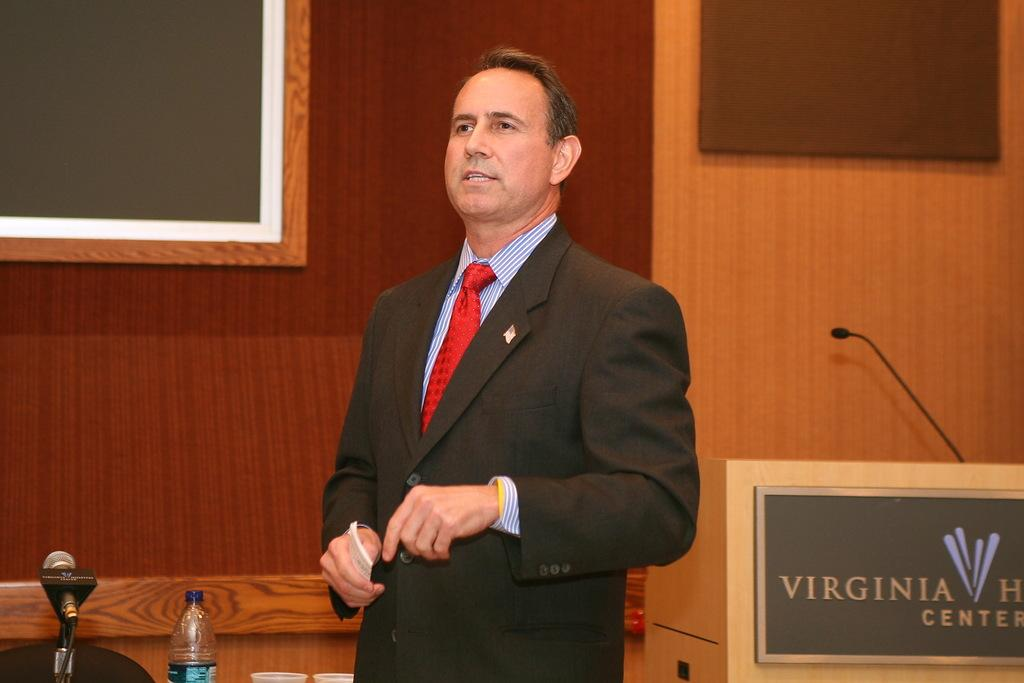<image>
Provide a brief description of the given image. A man is giving a talk next to a lectern that says Virginia something center. 